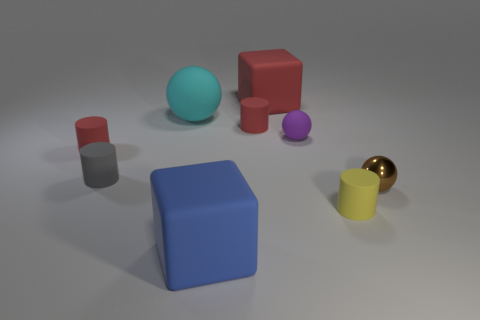There is a red thing that is the same size as the blue block; what is its material?
Your response must be concise. Rubber. Are there any gray blocks that have the same size as the purple rubber thing?
Offer a terse response. No. Does the gray rubber thing have the same shape as the large red rubber thing?
Give a very brief answer. No. There is a large matte block that is on the left side of the block behind the tiny rubber sphere; is there a tiny red rubber cylinder on the left side of it?
Offer a terse response. Yes. Do the matte cube in front of the red block and the cube that is behind the large cyan thing have the same size?
Ensure brevity in your answer.  Yes. Are there an equal number of cyan spheres that are on the left side of the large cyan ball and brown shiny balls that are behind the tiny gray cylinder?
Make the answer very short. Yes. Is there anything else that has the same material as the tiny purple ball?
Provide a succinct answer. Yes. There is a purple sphere; does it have the same size as the cylinder that is behind the tiny purple object?
Provide a short and direct response. Yes. There is a red cylinder on the right side of the cube in front of the small purple rubber object; what is it made of?
Offer a very short reply. Rubber. Is the number of small matte balls to the left of the cyan thing the same as the number of yellow cylinders?
Give a very brief answer. No. 